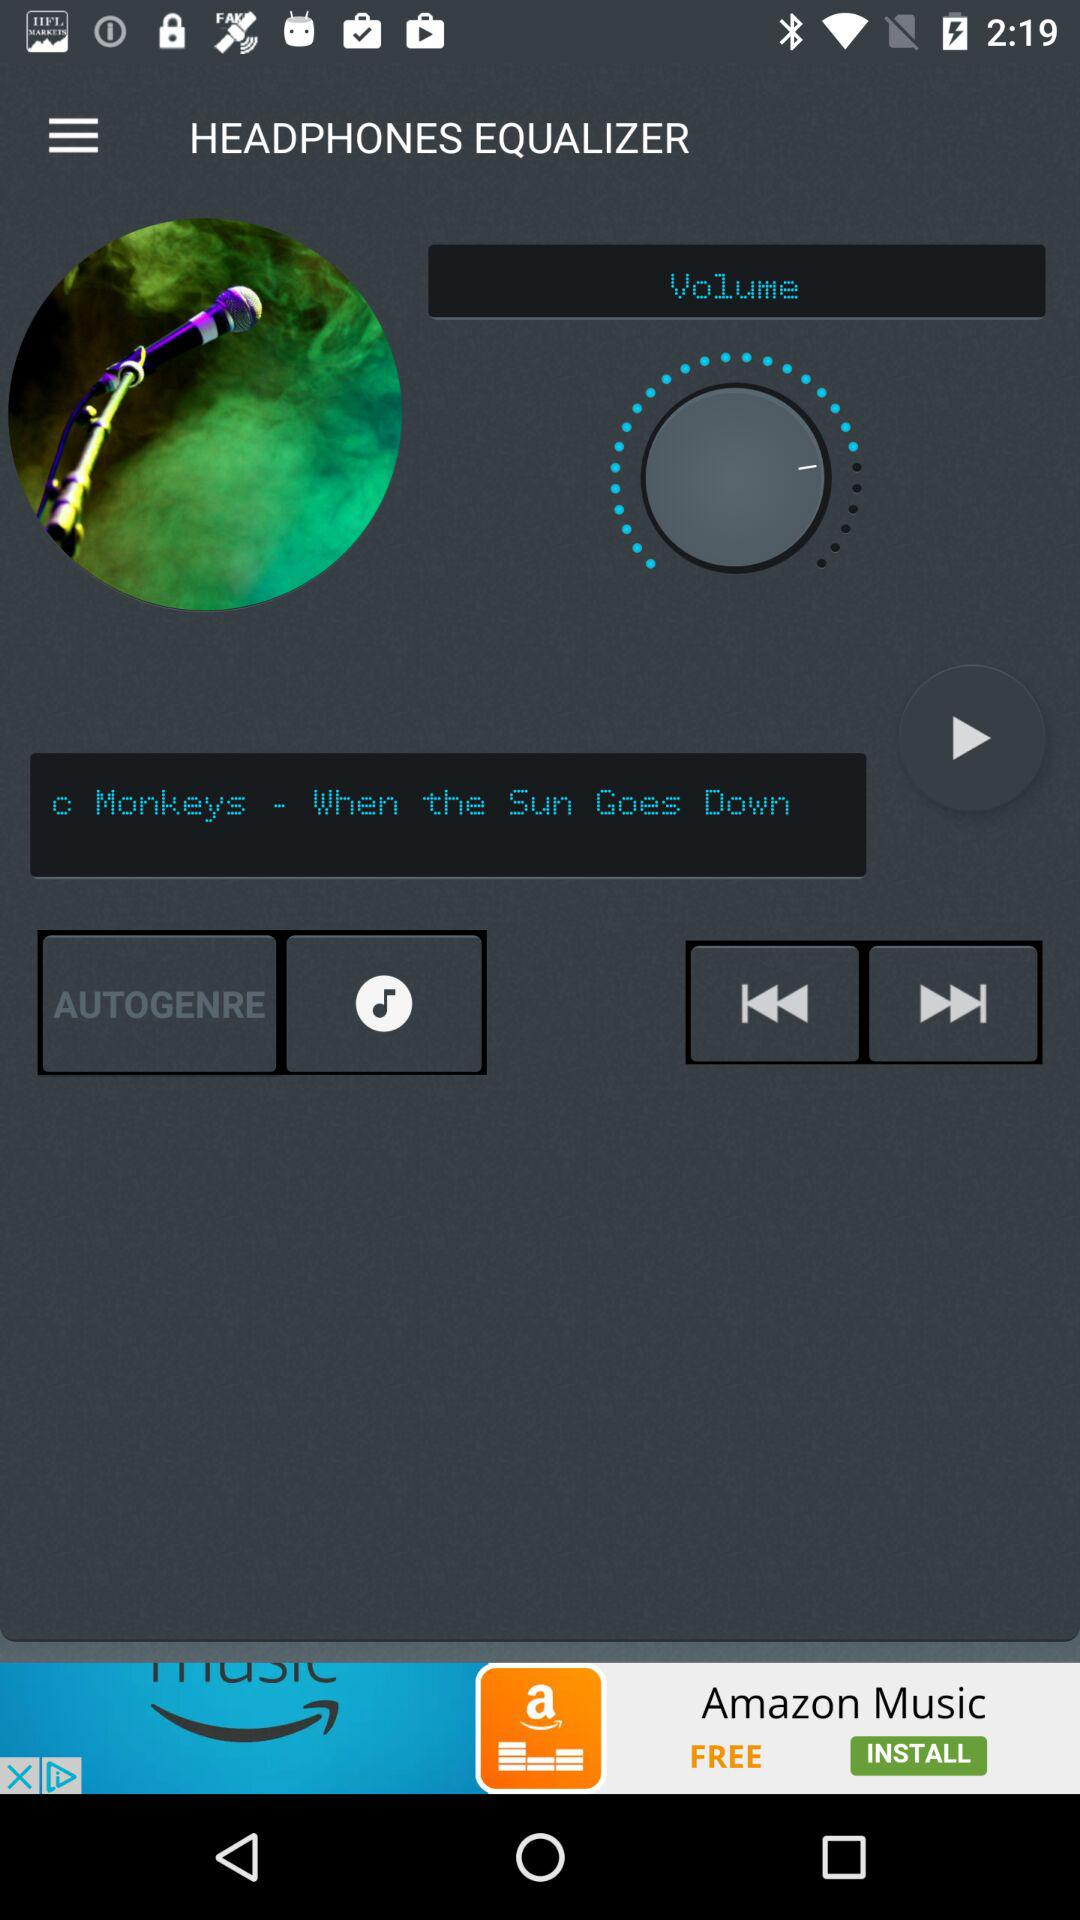What is the name of the application? The name of the application is "HEADPHONES EQUALIZER". 